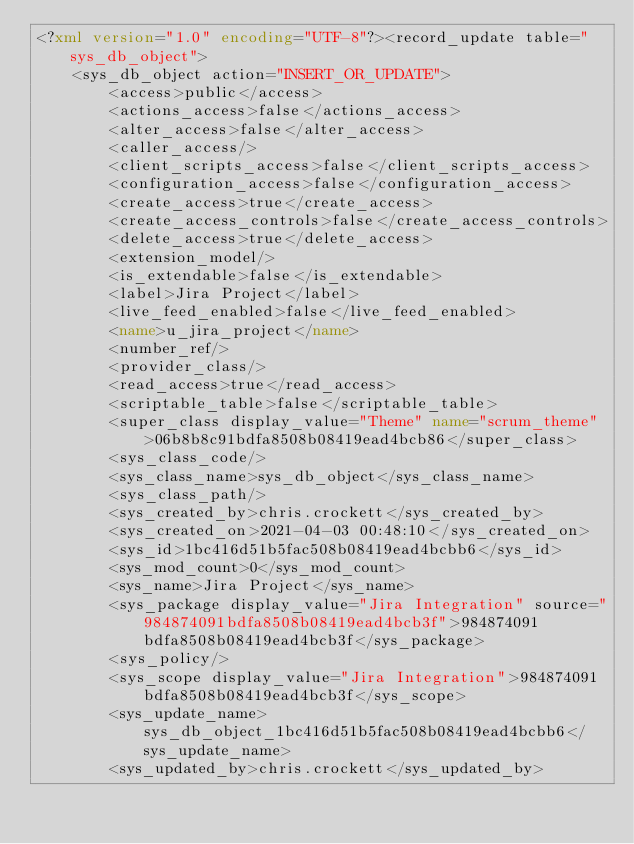<code> <loc_0><loc_0><loc_500><loc_500><_XML_><?xml version="1.0" encoding="UTF-8"?><record_update table="sys_db_object">
    <sys_db_object action="INSERT_OR_UPDATE">
        <access>public</access>
        <actions_access>false</actions_access>
        <alter_access>false</alter_access>
        <caller_access/>
        <client_scripts_access>false</client_scripts_access>
        <configuration_access>false</configuration_access>
        <create_access>true</create_access>
        <create_access_controls>false</create_access_controls>
        <delete_access>true</delete_access>
        <extension_model/>
        <is_extendable>false</is_extendable>
        <label>Jira Project</label>
        <live_feed_enabled>false</live_feed_enabled>
        <name>u_jira_project</name>
        <number_ref/>
        <provider_class/>
        <read_access>true</read_access>
        <scriptable_table>false</scriptable_table>
        <super_class display_value="Theme" name="scrum_theme">06b8b8c91bdfa8508b08419ead4bcb86</super_class>
        <sys_class_code/>
        <sys_class_name>sys_db_object</sys_class_name>
        <sys_class_path/>
        <sys_created_by>chris.crockett</sys_created_by>
        <sys_created_on>2021-04-03 00:48:10</sys_created_on>
        <sys_id>1bc416d51b5fac508b08419ead4bcbb6</sys_id>
        <sys_mod_count>0</sys_mod_count>
        <sys_name>Jira Project</sys_name>
        <sys_package display_value="Jira Integration" source="984874091bdfa8508b08419ead4bcb3f">984874091bdfa8508b08419ead4bcb3f</sys_package>
        <sys_policy/>
        <sys_scope display_value="Jira Integration">984874091bdfa8508b08419ead4bcb3f</sys_scope>
        <sys_update_name>sys_db_object_1bc416d51b5fac508b08419ead4bcbb6</sys_update_name>
        <sys_updated_by>chris.crockett</sys_updated_by></code> 